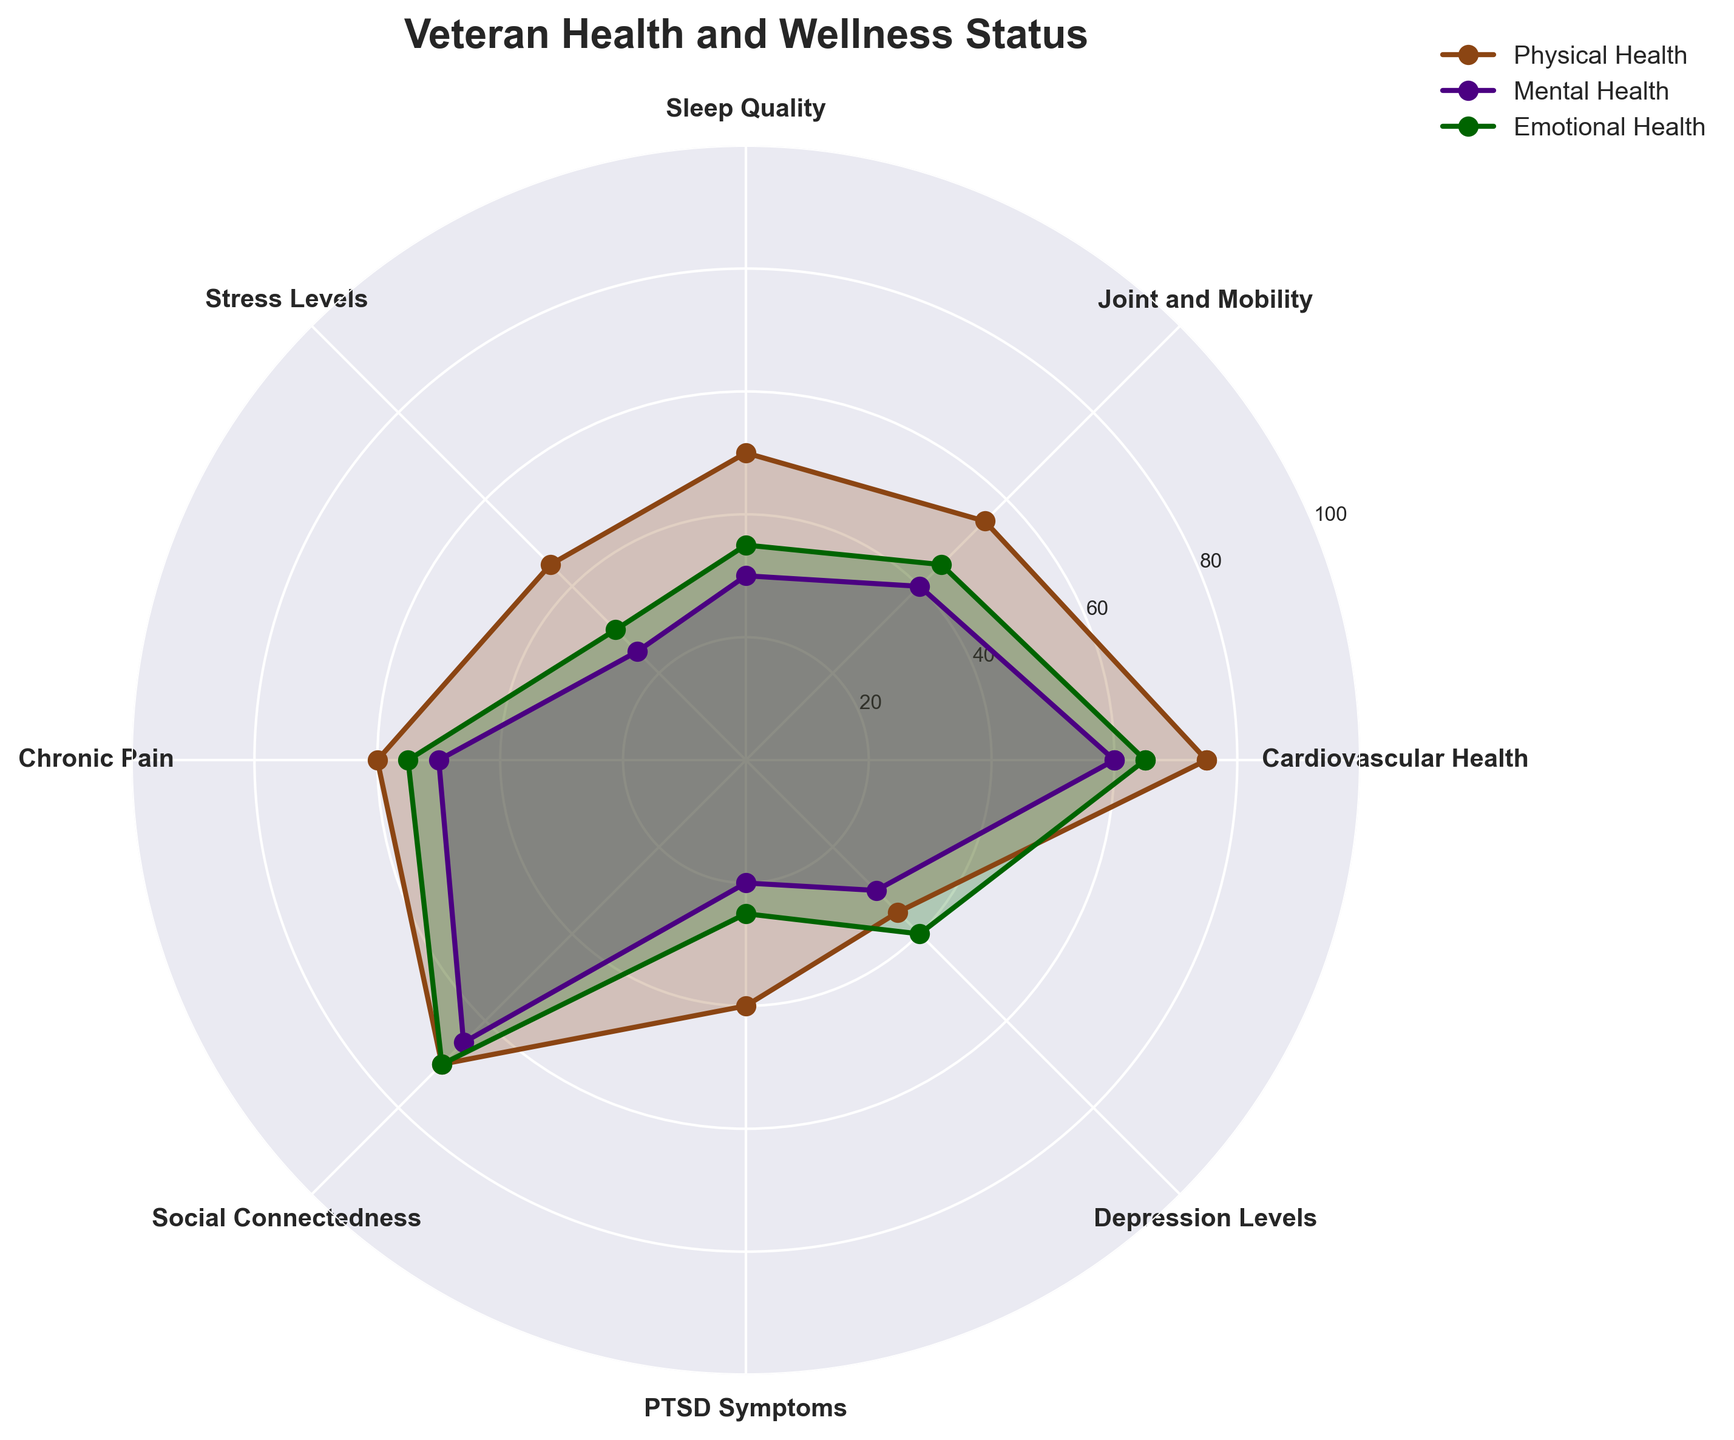Which category has the highest physical health value? The highest physical health value is represented by the furthest point from the center along the physical health line. By looking at the graph, Cardiovascular Health has the highest value at 75.
Answer: Cardiovascular Health Which category has the lowest mental health value? The lowest mental health value is represented by the closest point to the center along the mental health line. By looking at the graph, PTSD Symptoms has the lowest value at 20.
Answer: PTSD Symptoms Which category has the smallest difference between physical and mental health values? To find the smallest difference, compare the differences between physical and mental health across all categories. Calculating these: Cardiovascular Health (75-60=15), Joint and Mobility (55-40=15), Sleep Quality (50-30=20), Stress Levels (45-25=20), Chronic Pain (60-50=10), Social Connectedness (70-65=5), PTSD Symptoms (40-20=20), Depression Levels (35-30=5). The smallest differences are for Social Connectedness and Depression Levels, both at 5.
Answer: Social Connectedness and Depression Levels In which category is the emotional health value closest to the mental health value? Find where the emotional and mental health values are closest by calculating differences for all categories: Cardiovascular Health (65-60=5), Joint and Mobility (45-40=5), Sleep Quality (35-30=5), Stress Levels (30-25=5), Chronic Pain (55-50=5), Social Connectedness (70-65=5), PTSD Symptoms (25-20=5), Depression Levels (40-30=10). They all have an equal difference of 5 except Depression Levels.
Answer: All categories except Depression Levels Which category shows the highest values for both mental and emotional health? Look for the category where both mental and emotional health values are the highest. Social Connectedness has the highest values with mental health at 65 and emotional health at 70.
Answer: Social Connectedness Which health aspect (physical, mental, or emotional) shows the greatest variability across categories? To determine variability, look at the range (difference between the highest and lowest values) for each health aspect. Physical: 75-35=40, Mental: 65-20=45, Emotional: 70-25=45. The greatest variability in values is seen in both the mental and emotional health aspects.
Answer: Mental and Emotional Health What is the average physical health value across all categories? Sum all physical health values and divide by the number of categories: (75 + 55 + 50 + 45 + 60 + 70 + 40 + 35)/8 = 430/8 = 53.75.
Answer: 53.75 Which aspect of health is generally faring the worst across all categories? Compare the general trend of values for physical, mental, and emotional health. Mental health values are typically the lowest across most categories, indicating it is generally faring the worst.
Answer: Mental Health Which category shows the largest gap between physical and emotional health values? Calculate the gap between physical and emotional health for each category: Cardiovascular Health (75-65=10), Joint and Mobility (55-45=10), Sleep Quality (50-35=15), Stress Levels (45-30=15), Chronic Pain (60-55=5), Social Connectedness (70-70=0), PTSD Symptoms (40-25=15), Depression Levels (35-40=5). Sleep Quality, Stress Levels, and PTSD Symptoms each show a gap of 15.
Answer: Sleep Quality, Stress Levels, and PTSD Symptoms What is the overall trend of the data in terms of physical, mental, and emotional health for each category? The overall trend can be seen by looking at the pattern formed by each health aspect across categories. Generally, physical health scores are higher, mental health scores are the lowest, and emotional health scores are moderately placed between the two.
Answer: Physical > Emotional > Mental 